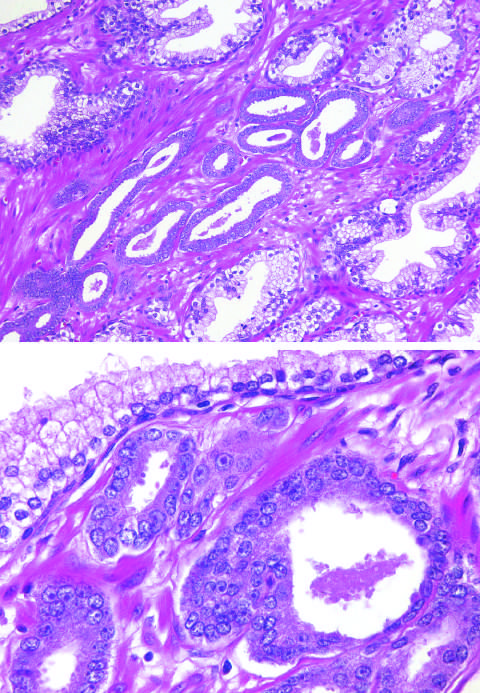what shows several small malignant glands with enlarged nuclei, prominent nucleoli, and dark cytoplasm, as compared with the larger, benign gland?
Answer the question using a single word or phrase. Higher magnification 